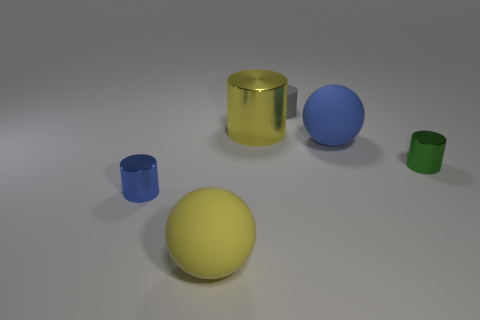Is there a big rubber ball of the same color as the large metal cylinder?
Your response must be concise. Yes. How many small objects are either gray matte objects or yellow shiny cylinders?
Offer a terse response. 1. The blue metallic object that is the same size as the rubber cylinder is what shape?
Ensure brevity in your answer.  Cylinder. The blue object to the right of the matte object that is in front of the small green metallic cylinder is made of what material?
Your response must be concise. Rubber. Is the yellow cylinder the same size as the yellow ball?
Give a very brief answer. Yes. How many objects are big objects to the right of the yellow rubber ball or tiny cylinders?
Your answer should be very brief. 5. There is a big yellow thing that is in front of the small metal thing on the left side of the yellow rubber object; what is its shape?
Provide a short and direct response. Sphere. Do the green object and the yellow thing right of the yellow matte object have the same size?
Make the answer very short. No. There is a sphere in front of the small blue shiny cylinder; what material is it?
Offer a very short reply. Rubber. How many objects are on the right side of the yellow cylinder and in front of the large metallic object?
Ensure brevity in your answer.  2. 